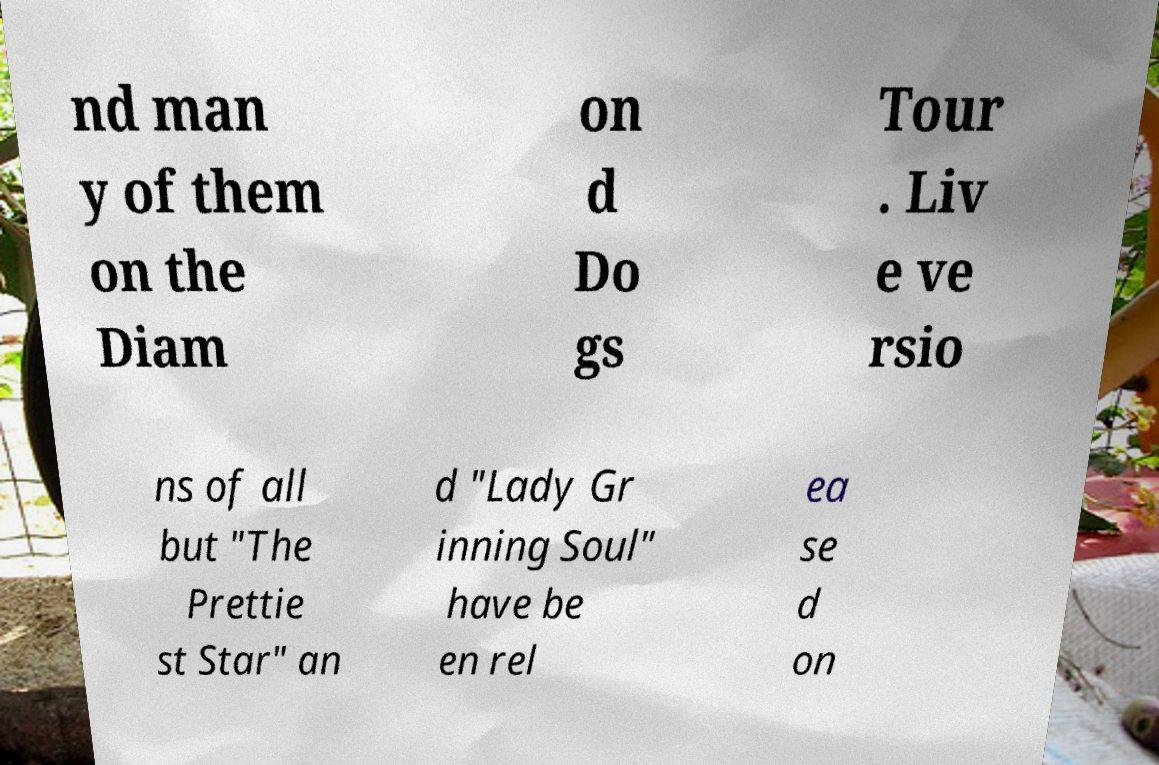I need the written content from this picture converted into text. Can you do that? nd man y of them on the Diam on d Do gs Tour . Liv e ve rsio ns of all but "The Prettie st Star" an d "Lady Gr inning Soul" have be en rel ea se d on 